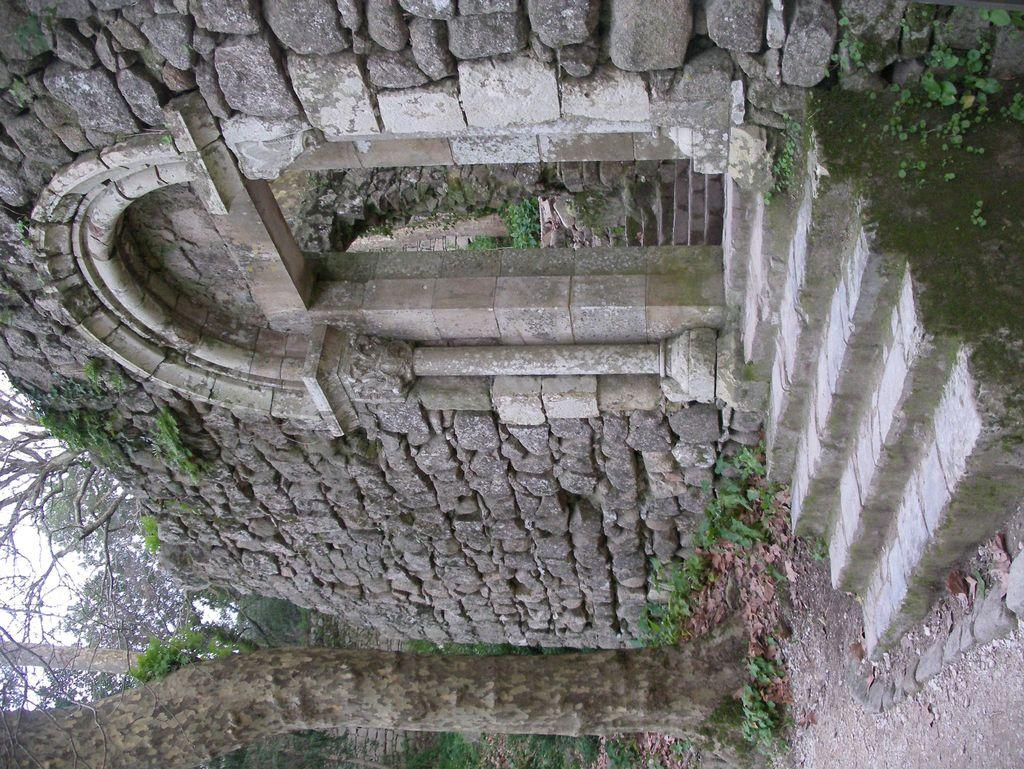How is the image oriented? The image is tilted. What can be seen in the image that is made up of rocks? There is a monument made up of rocks in the image. What is located in front of the rock wall in the image? There is a tree trunk in front of the rock wall in the image. What type of apparatus is being used to polish the rocks in the image? There is no apparatus or polishing activity visible in the image; it features a monument made up of rocks with a tree trunk in front of it. How many people are jumping in the image? There are no people or jumping activity present in the image. 